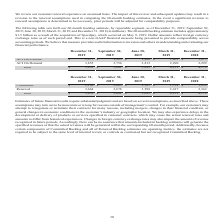According to Aci Worldwide's financial document, How much was the 60-month backlog estimate as a result of the acquisition of Speedpay? According to the financial document, $1.5 billion (in billions). The relevant text states: "e 60-month backlog estimate includes approximately $1.5 billion as a result of the acquisition of Speedpay, which occurred on May 9, 2019. Dollar amounts reflect fo..." Also, What was the committed backlog in December 31, 2019? According to the financial document, $2,168 (in millions). The relevant text states: "Committed $ 2,168 $ 2,003 $ 2,105 $ 1,734 $ 1,832..." Also, What was the committed backlog in June 30, 2019? According to the financial document, $2,105 (in millions). The relevant text states: "Committed $ 2,168 $ 2,003 $ 2,105 $ 1,734 $ 1,832..." Also, can you calculate: What was the difference in committed backlog between December 31 and September 30, 2019? Based on the calculation: ($2,168-$2,003), the result is 165 (in millions). This is based on the information: "Committed $ 2,168 $ 2,003 $ 2,105 $ 1,734 $ 1,832 Committed $ 2,168 $ 2,003 $ 2,105 $ 1,734 $ 1,832..." The key data points involved are: 2,003, 2,168. Also, can you calculate: What was the difference in Renewal backlog between June 30 and March 31, 2019? Based on the calculation: 3,588-2,417, the result is 1171 (in millions). This is based on the information: "Renewal 3,664 3,678 3,588 2,417 2,342 Renewal 3,664 3,678 3,588 2,417 2,342..." The key data points involved are: 2,417, 3,588. Also, can you calculate: What was the percentage change in ACI on premise between December 31 and September 30, 2019? To answer this question, I need to perform calculations using the financial data. The calculation is: ($1,977-$1,925)/$1,925, which equals 2.7 (percentage). This is based on the information: "ACI On Premise $ 1,977 $ 1,925 $ 1,880 $ 1,861 $ 1,875 ACI On Premise $ 1,977 $ 1,925 $ 1,880 $ 1,861 $ 1,875..." The key data points involved are: 1,925, 1,977. 